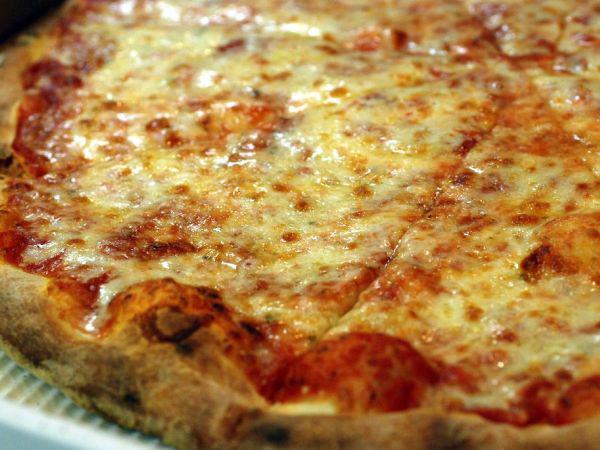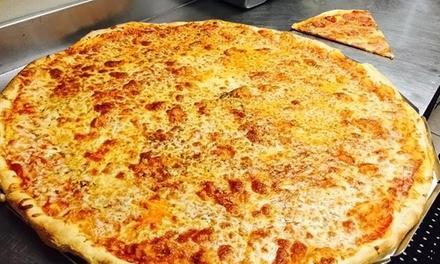The first image is the image on the left, the second image is the image on the right. For the images shown, is this caption "In one of the images the pizza is cut into squares." true? Answer yes or no. No. The first image is the image on the left, the second image is the image on the right. Evaluate the accuracy of this statement regarding the images: "One image shows a round pizza cut in triangular 'pie' slices, with a slice at least partly off, and the other image features a pizza cut in squares.". Is it true? Answer yes or no. No. 